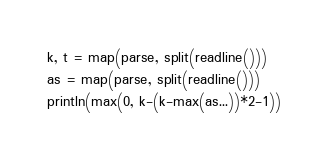Convert code to text. <code><loc_0><loc_0><loc_500><loc_500><_Julia_>k, t = map(parse, split(readline()))
as = map(parse, split(readline()))
println(max(0, k-(k-max(as...))*2-1))</code> 